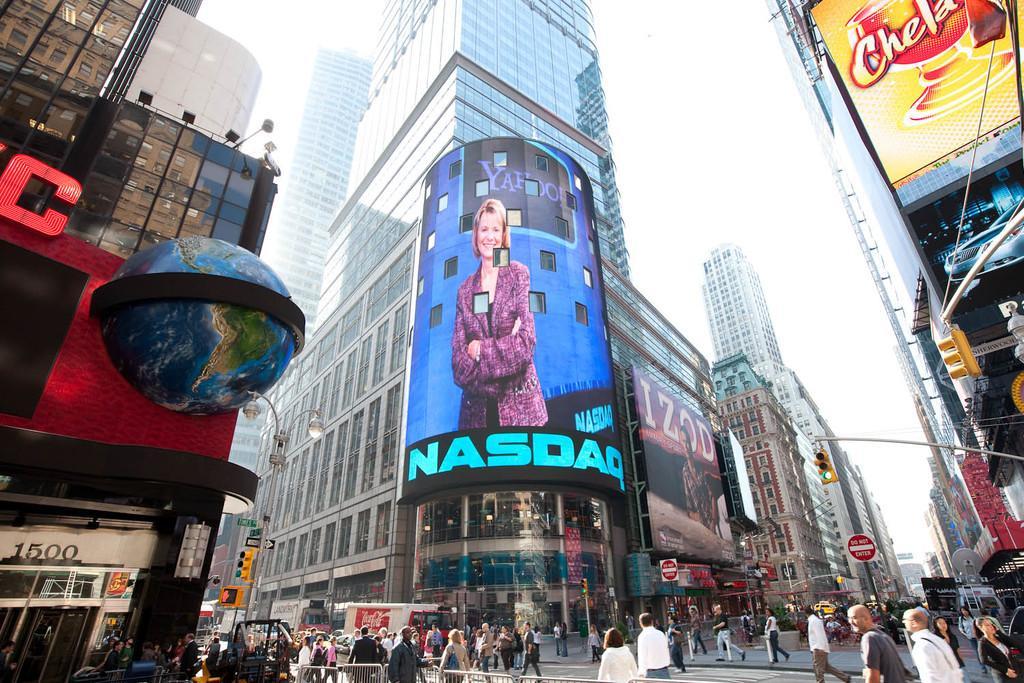Could you give a brief overview of what you see in this image? This picture is clicked outside the city. At the bottom of the picture, we see railing and many people are walking on the road. On either side of the picture, we see buildings. In the middle of the picture, we see poles and street lights. We see boards in white and red color with some text written on it. On the left side, we see traffic signals and street light. There are buildings in the background. At the top of the picture, we see the sky. 